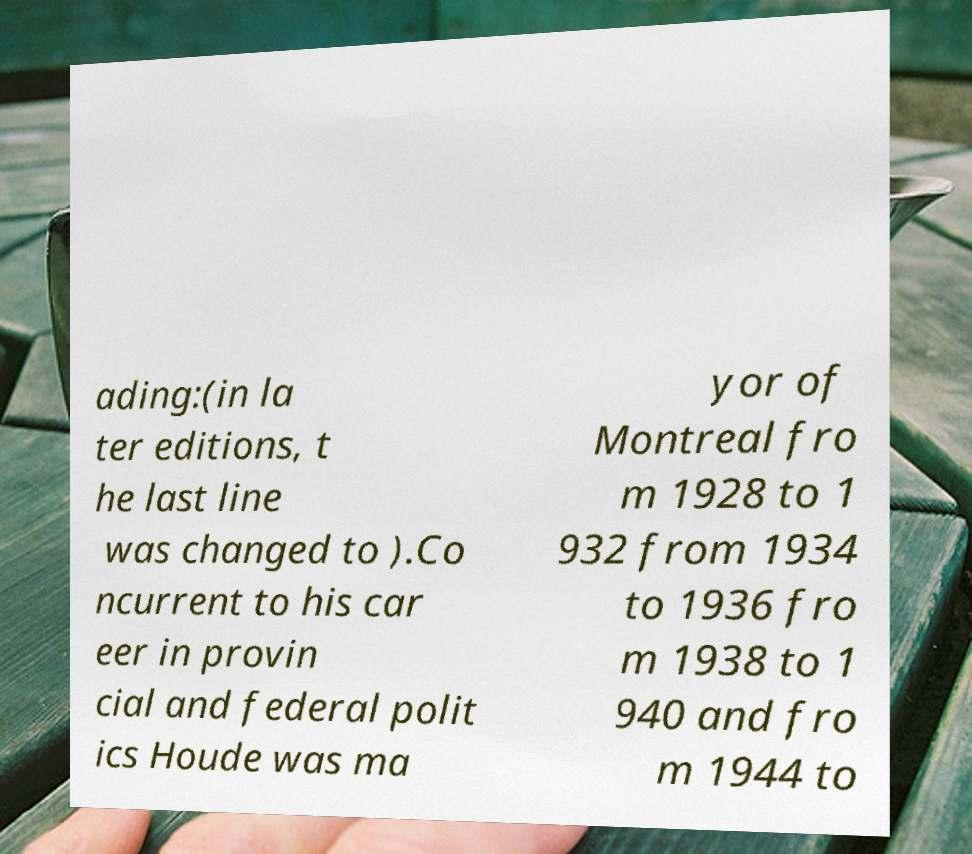What messages or text are displayed in this image? I need them in a readable, typed format. ading:(in la ter editions, t he last line was changed to ).Co ncurrent to his car eer in provin cial and federal polit ics Houde was ma yor of Montreal fro m 1928 to 1 932 from 1934 to 1936 fro m 1938 to 1 940 and fro m 1944 to 